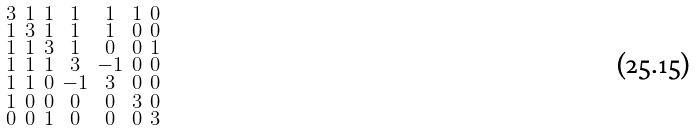<formula> <loc_0><loc_0><loc_500><loc_500>\begin{smallmatrix} 3 & 1 & 1 & 1 & 1 & 1 & 0 \\ 1 & 3 & 1 & 1 & 1 & 0 & 0 \\ 1 & 1 & 3 & 1 & 0 & 0 & 1 \\ 1 & 1 & 1 & 3 & - 1 & 0 & 0 \\ 1 & 1 & 0 & - 1 & 3 & 0 & 0 \\ 1 & 0 & 0 & 0 & 0 & 3 & 0 \\ 0 & 0 & 1 & 0 & 0 & 0 & 3 \end{smallmatrix}</formula> 